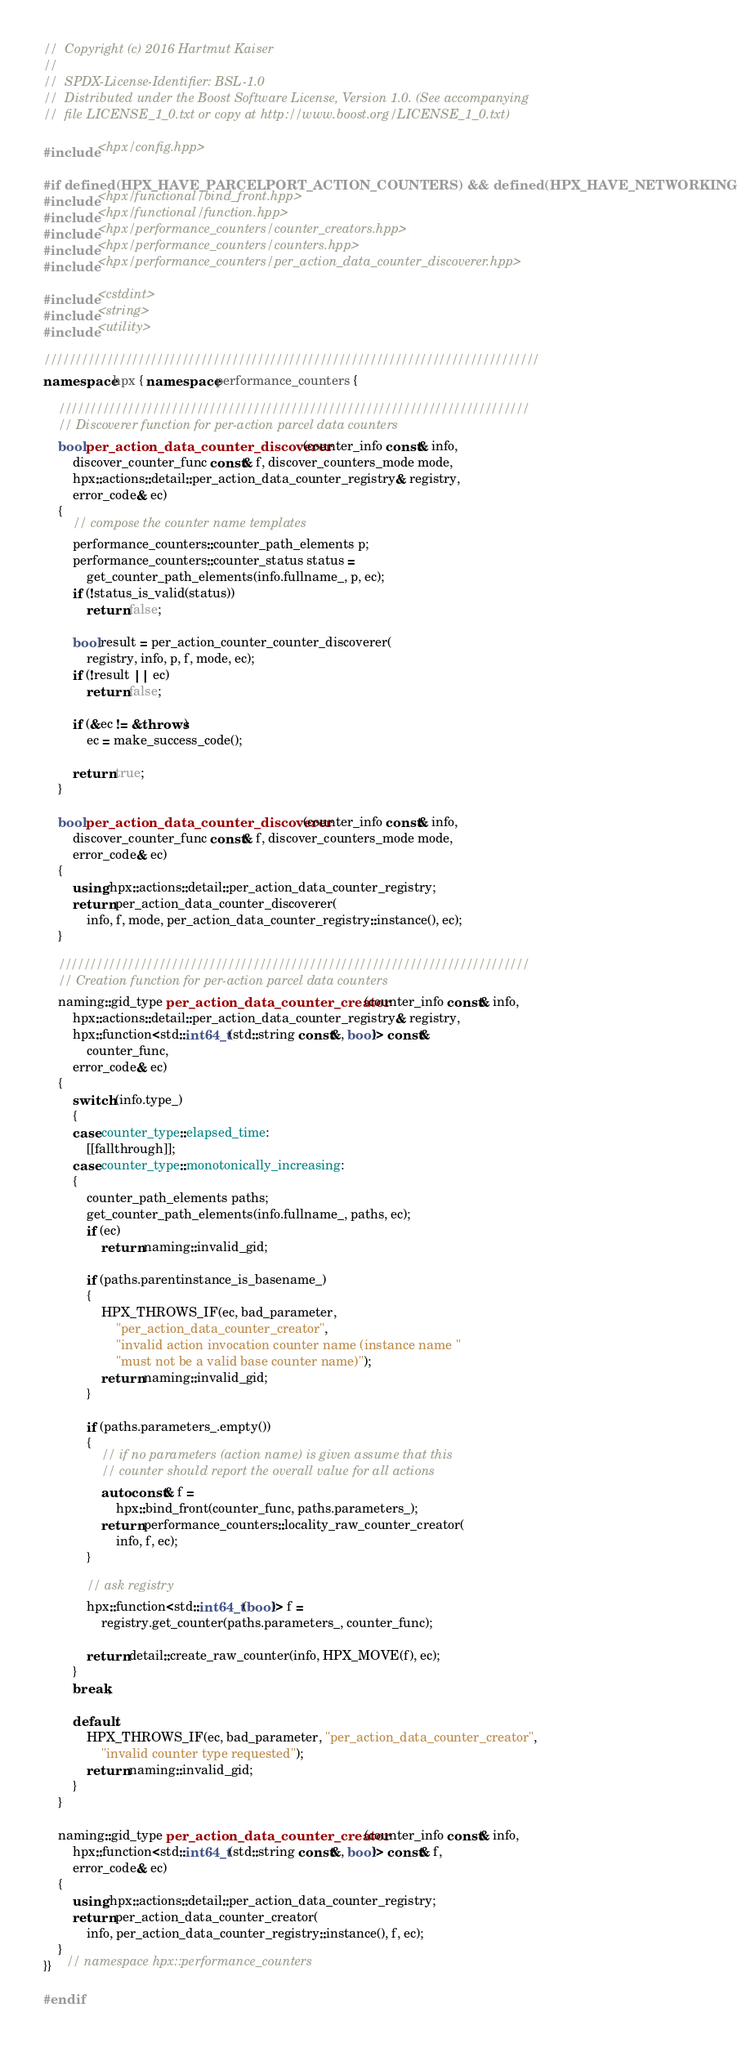<code> <loc_0><loc_0><loc_500><loc_500><_C++_>//  Copyright (c) 2016 Hartmut Kaiser
//
//  SPDX-License-Identifier: BSL-1.0
//  Distributed under the Boost Software License, Version 1.0. (See accompanying
//  file LICENSE_1_0.txt or copy at http://www.boost.org/LICENSE_1_0.txt)

#include <hpx/config.hpp>

#if defined(HPX_HAVE_PARCELPORT_ACTION_COUNTERS) && defined(HPX_HAVE_NETWORKING)
#include <hpx/functional/bind_front.hpp>
#include <hpx/functional/function.hpp>
#include <hpx/performance_counters/counter_creators.hpp>
#include <hpx/performance_counters/counters.hpp>
#include <hpx/performance_counters/per_action_data_counter_discoverer.hpp>

#include <cstdint>
#include <string>
#include <utility>

///////////////////////////////////////////////////////////////////////////////
namespace hpx { namespace performance_counters {

    ///////////////////////////////////////////////////////////////////////////
    // Discoverer function for per-action parcel data counters
    bool per_action_data_counter_discoverer(counter_info const& info,
        discover_counter_func const& f, discover_counters_mode mode,
        hpx::actions::detail::per_action_data_counter_registry& registry,
        error_code& ec)
    {
        // compose the counter name templates
        performance_counters::counter_path_elements p;
        performance_counters::counter_status status =
            get_counter_path_elements(info.fullname_, p, ec);
        if (!status_is_valid(status))
            return false;

        bool result = per_action_counter_counter_discoverer(
            registry, info, p, f, mode, ec);
        if (!result || ec)
            return false;

        if (&ec != &throws)
            ec = make_success_code();

        return true;
    }

    bool per_action_data_counter_discoverer(counter_info const& info,
        discover_counter_func const& f, discover_counters_mode mode,
        error_code& ec)
    {
        using hpx::actions::detail::per_action_data_counter_registry;
        return per_action_data_counter_discoverer(
            info, f, mode, per_action_data_counter_registry::instance(), ec);
    }

    ///////////////////////////////////////////////////////////////////////////
    // Creation function for per-action parcel data counters
    naming::gid_type per_action_data_counter_creator(counter_info const& info,
        hpx::actions::detail::per_action_data_counter_registry& registry,
        hpx::function<std::int64_t(std::string const&, bool)> const&
            counter_func,
        error_code& ec)
    {
        switch (info.type_)
        {
        case counter_type::elapsed_time:
            [[fallthrough]];
        case counter_type::monotonically_increasing:
        {
            counter_path_elements paths;
            get_counter_path_elements(info.fullname_, paths, ec);
            if (ec)
                return naming::invalid_gid;

            if (paths.parentinstance_is_basename_)
            {
                HPX_THROWS_IF(ec, bad_parameter,
                    "per_action_data_counter_creator",
                    "invalid action invocation counter name (instance name "
                    "must not be a valid base counter name)");
                return naming::invalid_gid;
            }

            if (paths.parameters_.empty())
            {
                // if no parameters (action name) is given assume that this
                // counter should report the overall value for all actions
                auto const& f =
                    hpx::bind_front(counter_func, paths.parameters_);
                return performance_counters::locality_raw_counter_creator(
                    info, f, ec);
            }

            // ask registry
            hpx::function<std::int64_t(bool)> f =
                registry.get_counter(paths.parameters_, counter_func);

            return detail::create_raw_counter(info, HPX_MOVE(f), ec);
        }
        break;

        default:
            HPX_THROWS_IF(ec, bad_parameter, "per_action_data_counter_creator",
                "invalid counter type requested");
            return naming::invalid_gid;
        }
    }

    naming::gid_type per_action_data_counter_creator(counter_info const& info,
        hpx::function<std::int64_t(std::string const&, bool)> const& f,
        error_code& ec)
    {
        using hpx::actions::detail::per_action_data_counter_registry;
        return per_action_data_counter_creator(
            info, per_action_data_counter_registry::instance(), f, ec);
    }
}}    // namespace hpx::performance_counters

#endif
</code> 